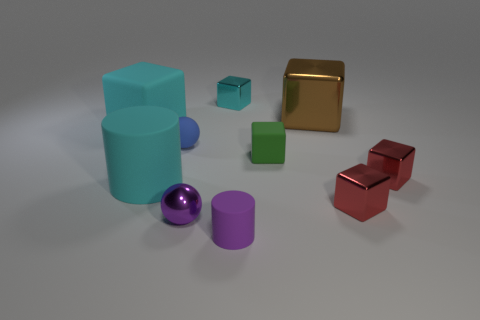What color is the tiny shiny sphere?
Give a very brief answer. Purple. How many small purple balls have the same material as the brown object?
Your response must be concise. 1. Is the number of small cubes greater than the number of small shiny cylinders?
Provide a succinct answer. Yes. How many tiny blocks are in front of the large thing right of the tiny green thing?
Make the answer very short. 3. How many objects are large blocks to the right of the blue matte ball or tiny metallic objects?
Your answer should be compact. 5. Are there any other objects of the same shape as the big brown thing?
Your response must be concise. Yes. There is a purple thing behind the small rubber thing in front of the green thing; what is its shape?
Offer a very short reply. Sphere. What number of blocks are either small objects or large cyan things?
Your response must be concise. 5. There is a small object that is the same color as the big matte cylinder; what is it made of?
Your answer should be very brief. Metal. There is a cyan object that is in front of the green rubber object; is it the same shape as the large cyan matte object behind the small blue matte object?
Ensure brevity in your answer.  No. 